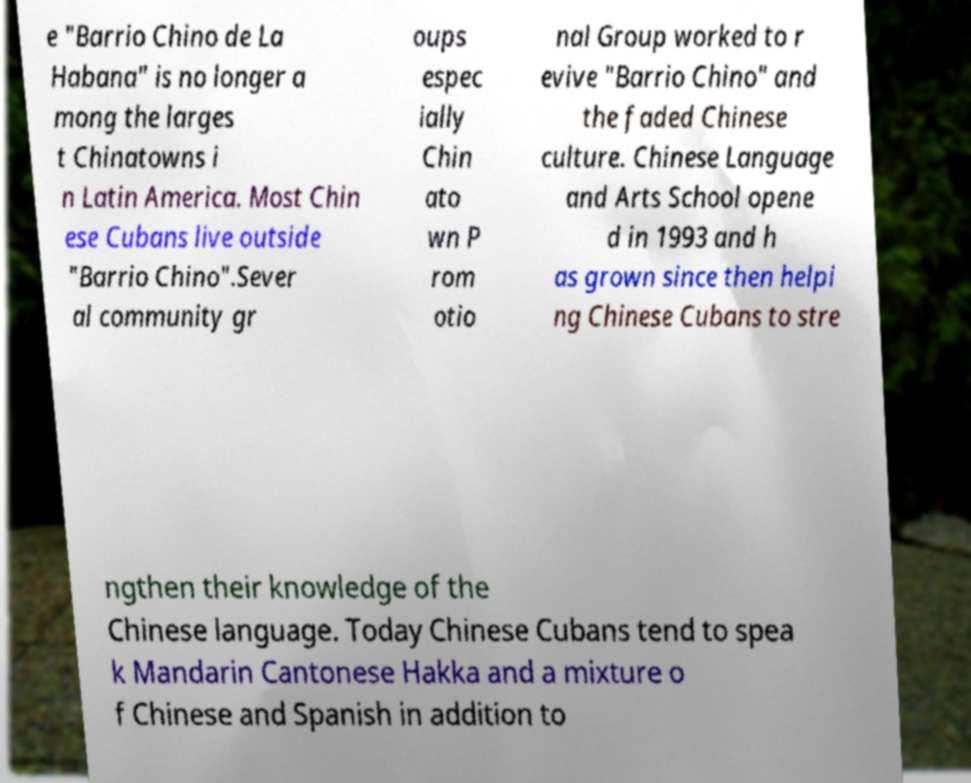Could you extract and type out the text from this image? e "Barrio Chino de La Habana" is no longer a mong the larges t Chinatowns i n Latin America. Most Chin ese Cubans live outside "Barrio Chino".Sever al community gr oups espec ially Chin ato wn P rom otio nal Group worked to r evive "Barrio Chino" and the faded Chinese culture. Chinese Language and Arts School opene d in 1993 and h as grown since then helpi ng Chinese Cubans to stre ngthen their knowledge of the Chinese language. Today Chinese Cubans tend to spea k Mandarin Cantonese Hakka and a mixture o f Chinese and Spanish in addition to 